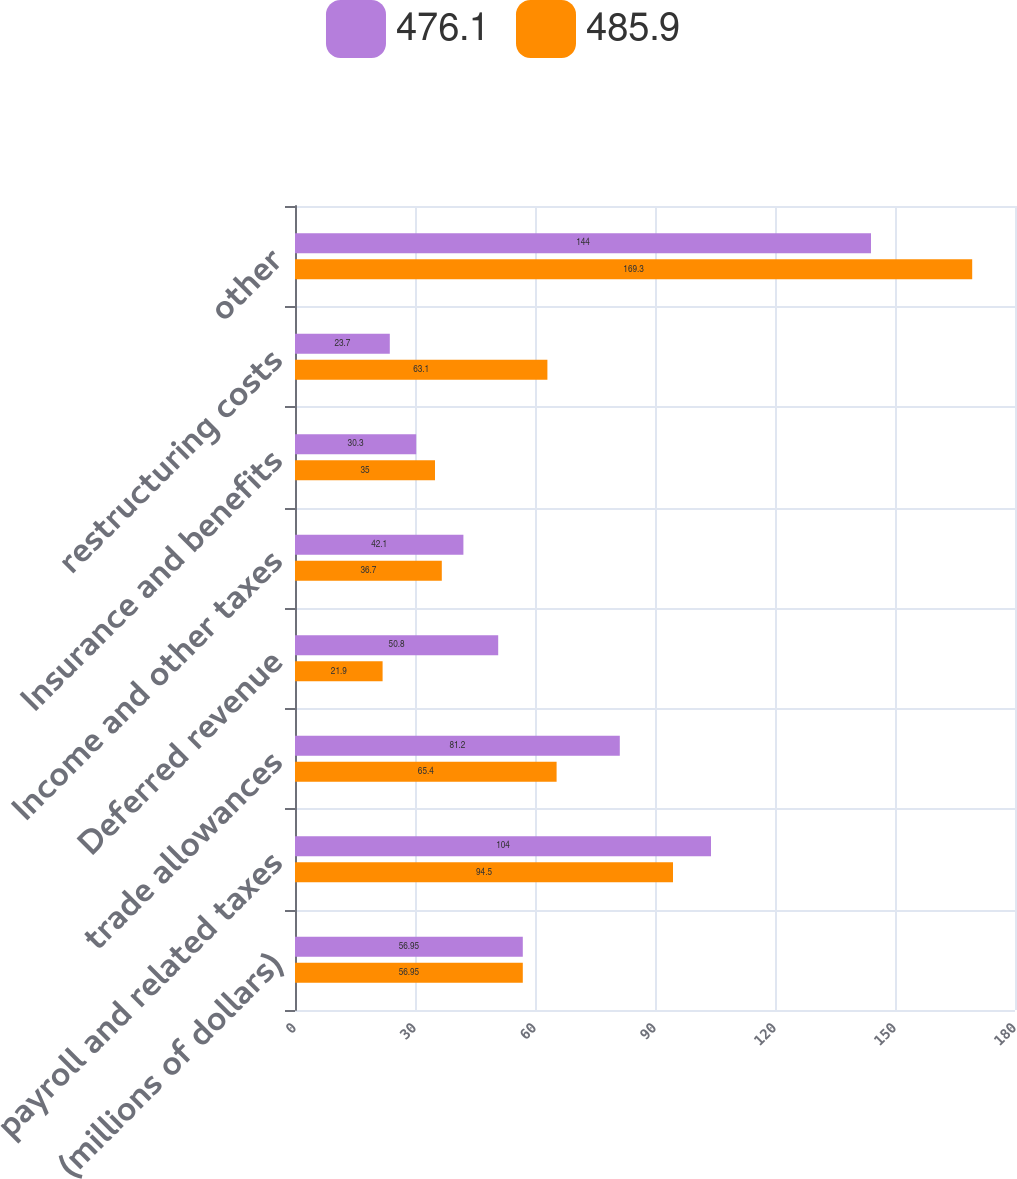<chart> <loc_0><loc_0><loc_500><loc_500><stacked_bar_chart><ecel><fcel>(millions of dollars)<fcel>payroll and related taxes<fcel>trade allowances<fcel>Deferred revenue<fcel>Income and other taxes<fcel>Insurance and benefits<fcel>restructuring costs<fcel>other<nl><fcel>476.1<fcel>56.95<fcel>104<fcel>81.2<fcel>50.8<fcel>42.1<fcel>30.3<fcel>23.7<fcel>144<nl><fcel>485.9<fcel>56.95<fcel>94.5<fcel>65.4<fcel>21.9<fcel>36.7<fcel>35<fcel>63.1<fcel>169.3<nl></chart> 